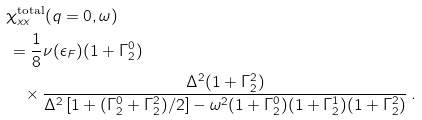<formula> <loc_0><loc_0><loc_500><loc_500>& \chi _ { x x } ^ { \text {total} } ( q = 0 , \omega ) \\ & \, = \frac { 1 } { 8 } \nu ( \epsilon _ { F } ) ( 1 + \Gamma _ { 2 } ^ { 0 } ) \\ & \quad \times \frac { \Delta ^ { 2 } ( 1 + \Gamma _ { 2 } ^ { 2 } ) } { \Delta ^ { 2 } \left [ 1 + ( \Gamma _ { 2 } ^ { 0 } + \Gamma _ { 2 } ^ { 2 } ) / 2 \right ] - \omega ^ { 2 } ( 1 + \Gamma _ { 2 } ^ { 0 } ) ( 1 + \Gamma _ { 2 } ^ { 1 } ) ( 1 + \Gamma _ { 2 } ^ { 2 } ) } \, .</formula> 